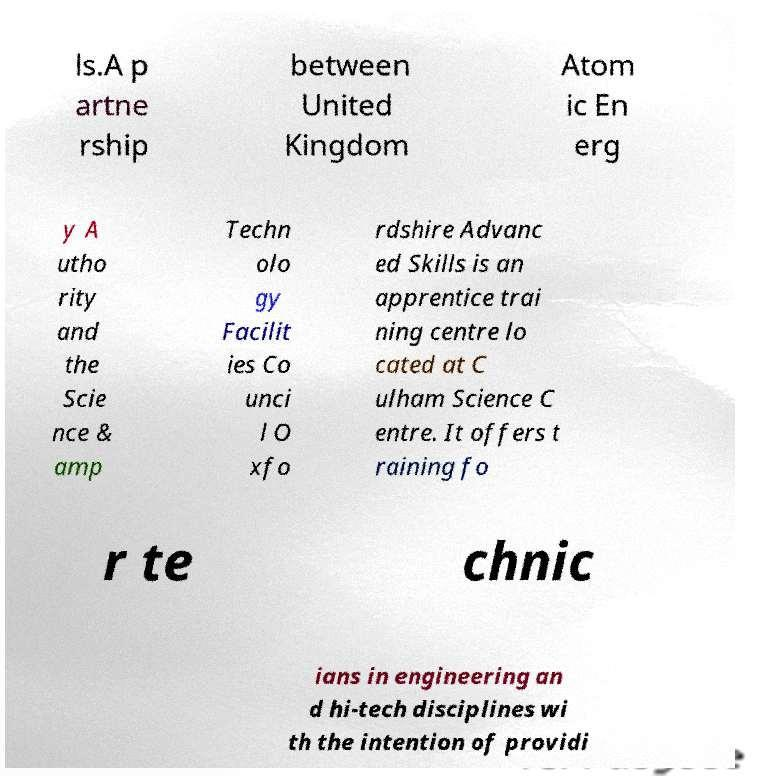Please read and relay the text visible in this image. What does it say? ls.A p artne rship between United Kingdom Atom ic En erg y A utho rity and the Scie nce & amp Techn olo gy Facilit ies Co unci l O xfo rdshire Advanc ed Skills is an apprentice trai ning centre lo cated at C ulham Science C entre. It offers t raining fo r te chnic ians in engineering an d hi-tech disciplines wi th the intention of providi 